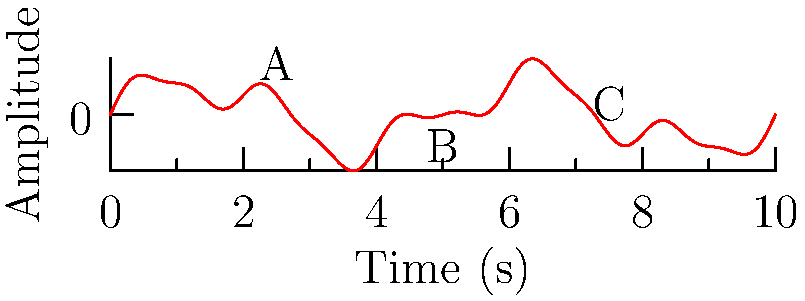In the waveform above, which point represents the most likely occurrence of an infrasonic frequency associated with potential ghostly activity? To identify the point most likely representing an infrasonic frequency associated with ghostly activity, we need to consider the following steps:

1. Infrasonic frequencies are typically defined as sound waves below the lower limit of human hearing, which is approximately 20 Hz.

2. In a waveform, lower frequencies are represented by longer wavelengths (greater distance between peaks).

3. Analyzing the given waveform:
   - Point A: Shows a relatively high-frequency component with short wavelength.
   - Point B: Represents the lowest frequency component visible, with the longest wavelength.
   - Point C: Displays a medium frequency component, between A and B.

4. Ghostly activity is often associated with very low frequencies, typically in the infrasonic range.

5. Among the three points, B clearly represents the lowest frequency component, making it the most likely candidate for an infrasonic frequency that could be associated with ghostly activity.

Therefore, point B is the most probable location for an infrasonic frequency potentially linked to ghostly phenomena.
Answer: B 